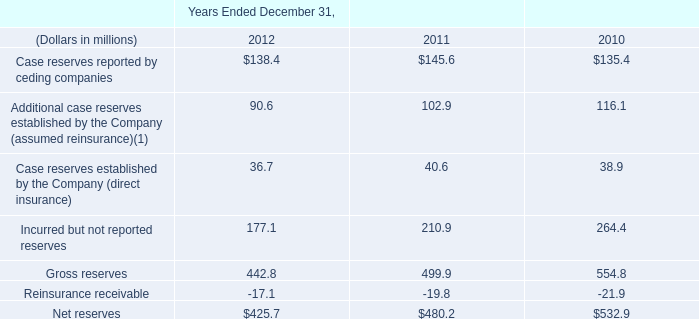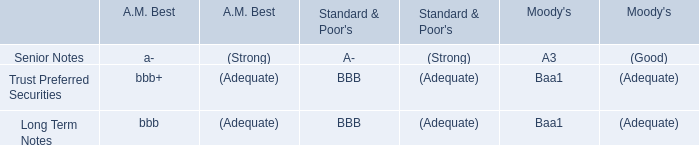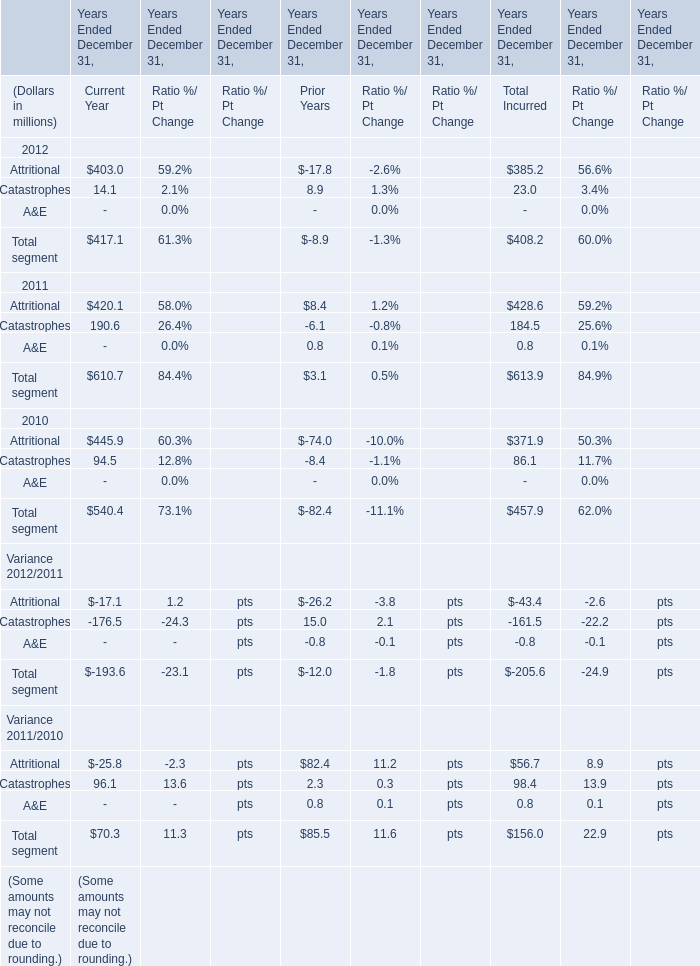What was the total amount of current year in 2012? (in million) 
Computations: (403 + 14.1)
Answer: 417.1. 